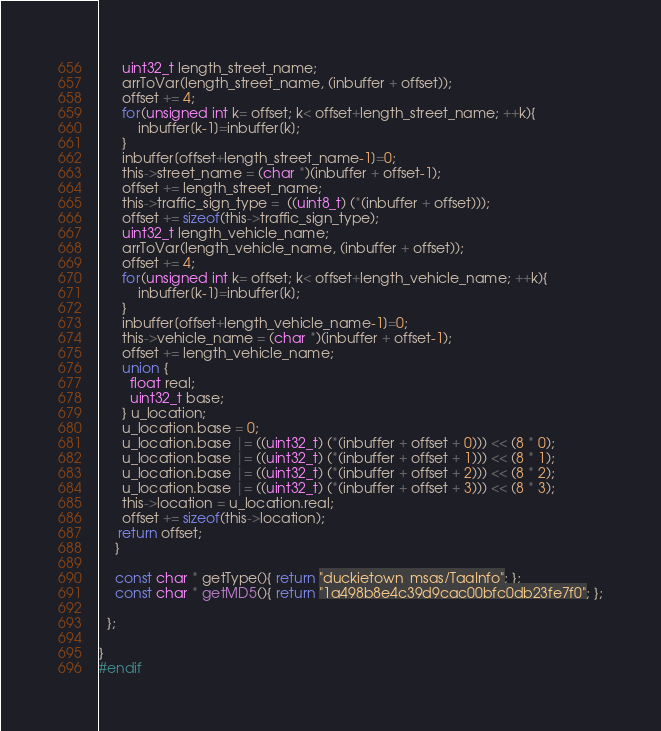Convert code to text. <code><loc_0><loc_0><loc_500><loc_500><_C_>      uint32_t length_street_name;
      arrToVar(length_street_name, (inbuffer + offset));
      offset += 4;
      for(unsigned int k= offset; k< offset+length_street_name; ++k){
          inbuffer[k-1]=inbuffer[k];
      }
      inbuffer[offset+length_street_name-1]=0;
      this->street_name = (char *)(inbuffer + offset-1);
      offset += length_street_name;
      this->traffic_sign_type =  ((uint8_t) (*(inbuffer + offset)));
      offset += sizeof(this->traffic_sign_type);
      uint32_t length_vehicle_name;
      arrToVar(length_vehicle_name, (inbuffer + offset));
      offset += 4;
      for(unsigned int k= offset; k< offset+length_vehicle_name; ++k){
          inbuffer[k-1]=inbuffer[k];
      }
      inbuffer[offset+length_vehicle_name-1]=0;
      this->vehicle_name = (char *)(inbuffer + offset-1);
      offset += length_vehicle_name;
      union {
        float real;
        uint32_t base;
      } u_location;
      u_location.base = 0;
      u_location.base |= ((uint32_t) (*(inbuffer + offset + 0))) << (8 * 0);
      u_location.base |= ((uint32_t) (*(inbuffer + offset + 1))) << (8 * 1);
      u_location.base |= ((uint32_t) (*(inbuffer + offset + 2))) << (8 * 2);
      u_location.base |= ((uint32_t) (*(inbuffer + offset + 3))) << (8 * 3);
      this->location = u_location.real;
      offset += sizeof(this->location);
     return offset;
    }

    const char * getType(){ return "duckietown_msgs/TagInfo"; };
    const char * getMD5(){ return "1a498b8e4c39d9cac00bfc0db23fe7f0"; };

  };

}
#endif</code> 